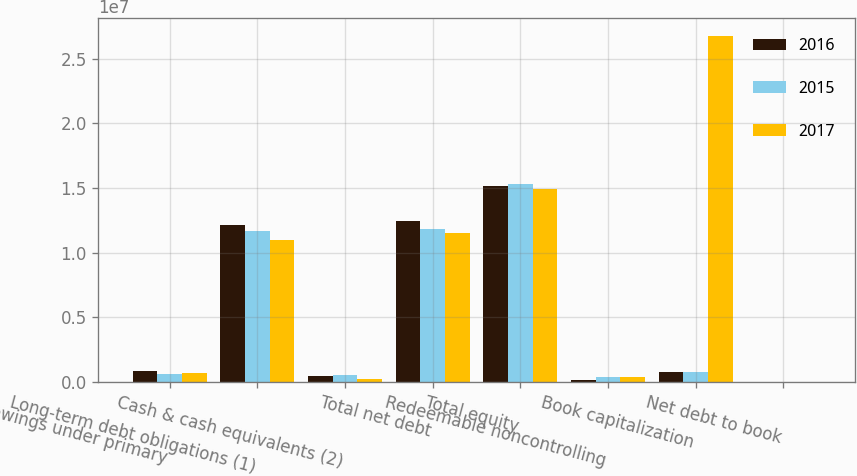Convert chart to OTSL. <chart><loc_0><loc_0><loc_500><loc_500><stacked_bar_chart><ecel><fcel>Borrowings under primary<fcel>Long-term debt obligations (1)<fcel>Cash & cash equivalents (2)<fcel>Total net debt<fcel>Total equity<fcel>Redeemable noncontrolling<fcel>Book capitalization<fcel>Net debt to book<nl><fcel>2016<fcel>835000<fcel>1.21327e+07<fcel>484754<fcel>1.24829e+07<fcel>1.51759e+07<fcel>183083<fcel>777000<fcel>44.8<nl><fcel>2015<fcel>645000<fcel>1.17132e+07<fcel>557659<fcel>1.18006e+07<fcel>1.52815e+07<fcel>398433<fcel>777000<fcel>42.9<nl><fcel>2017<fcel>719000<fcel>1.10129e+07<fcel>249620<fcel>1.14823e+07<fcel>1.49255e+07<fcel>375194<fcel>2.6783e+07<fcel>42.9<nl></chart> 